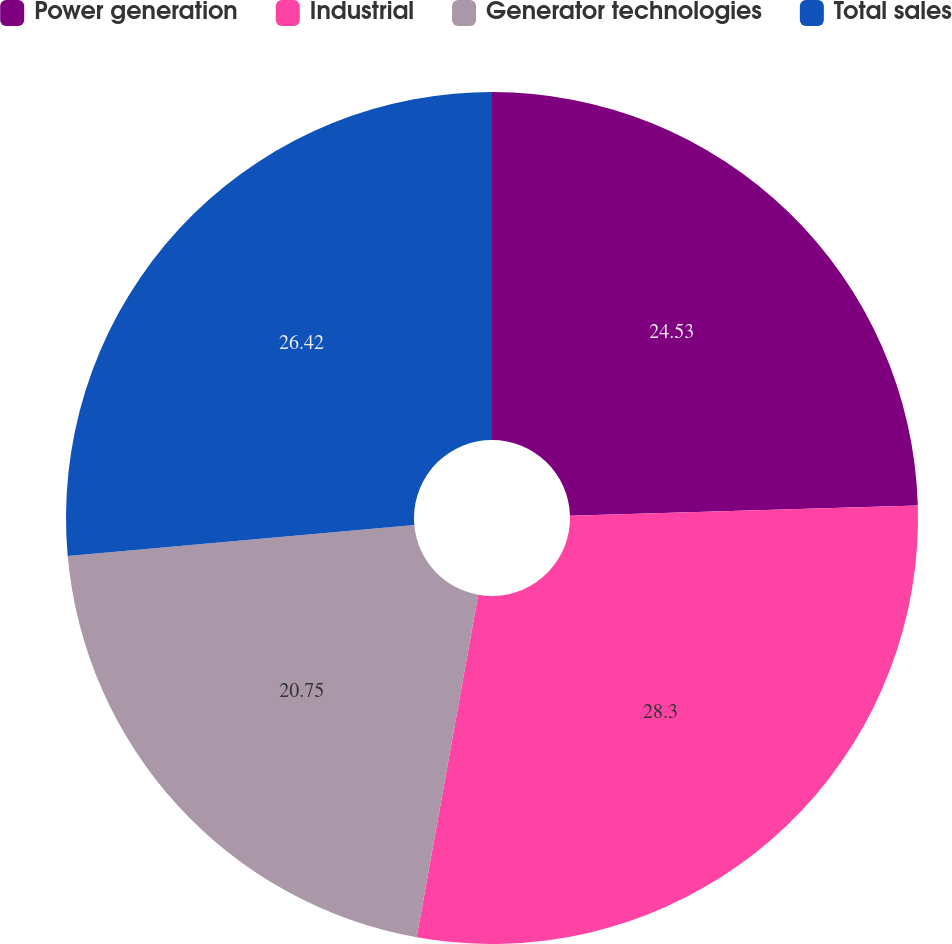Convert chart. <chart><loc_0><loc_0><loc_500><loc_500><pie_chart><fcel>Power generation<fcel>Industrial<fcel>Generator technologies<fcel>Total sales<nl><fcel>24.53%<fcel>28.3%<fcel>20.75%<fcel>26.42%<nl></chart> 